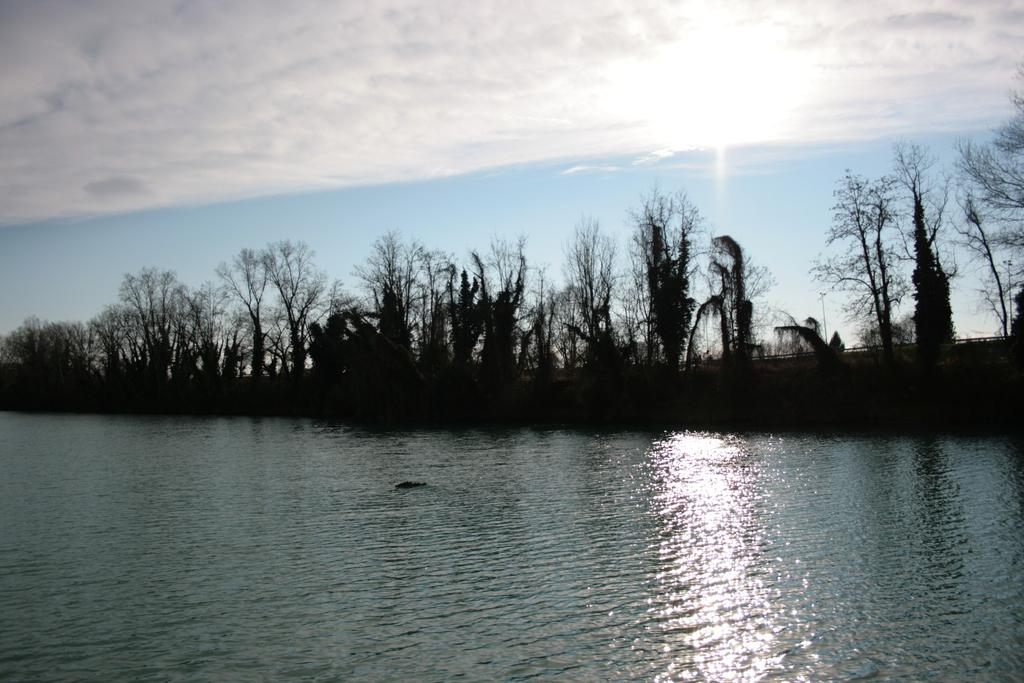What body of water is visible in the image? There is a pond in the image. What can be seen behind the pond? There are many trees behind the pond. What part of the natural environment is visible in the image? The sky is visible in the image. What is present in the sky? Clouds are present in the sky. Where is the throne located in the image? There is no throne present in the image. How many geese are swimming in the pond in the image? There are no geese visible in the image; it only features a pond and trees. 